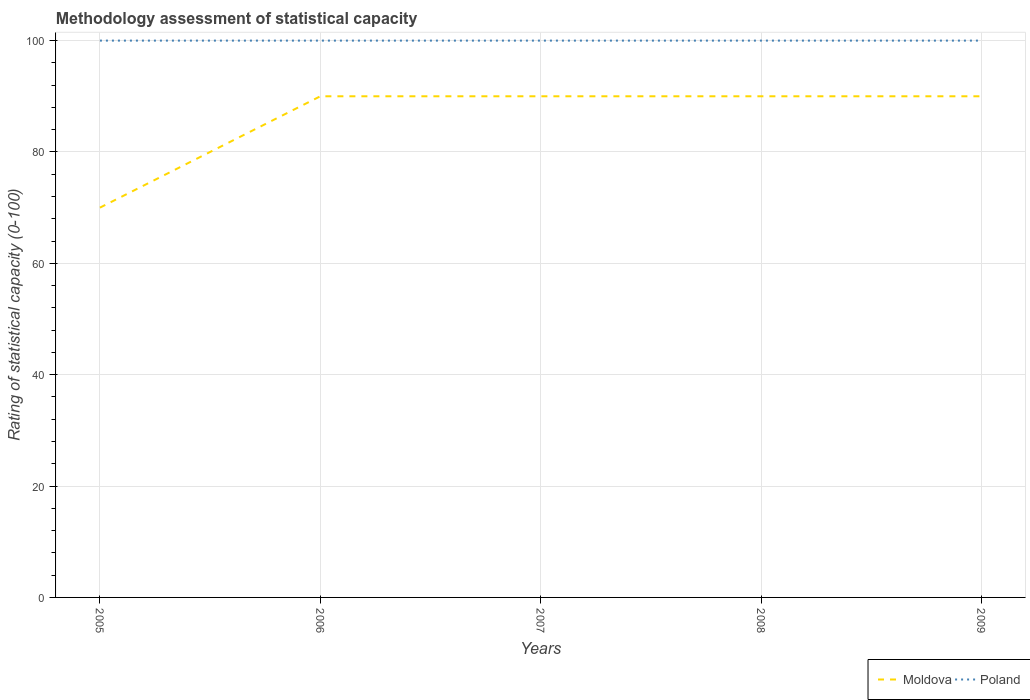How many different coloured lines are there?
Provide a succinct answer. 2. Across all years, what is the maximum rating of statistical capacity in Moldova?
Provide a succinct answer. 70. What is the difference between the highest and the second highest rating of statistical capacity in Poland?
Your response must be concise. 0. What is the difference between two consecutive major ticks on the Y-axis?
Your answer should be very brief. 20. Does the graph contain any zero values?
Your answer should be compact. No. Where does the legend appear in the graph?
Keep it short and to the point. Bottom right. How many legend labels are there?
Your response must be concise. 2. How are the legend labels stacked?
Provide a short and direct response. Horizontal. What is the title of the graph?
Your answer should be compact. Methodology assessment of statistical capacity. What is the label or title of the Y-axis?
Give a very brief answer. Rating of statistical capacity (0-100). What is the Rating of statistical capacity (0-100) of Poland in 2005?
Your answer should be very brief. 100. What is the Rating of statistical capacity (0-100) of Moldova in 2006?
Your response must be concise. 90. What is the Rating of statistical capacity (0-100) in Moldova in 2007?
Keep it short and to the point. 90. What is the Rating of statistical capacity (0-100) of Poland in 2007?
Ensure brevity in your answer.  100. What is the Rating of statistical capacity (0-100) of Moldova in 2008?
Ensure brevity in your answer.  90. What is the Rating of statistical capacity (0-100) in Poland in 2008?
Provide a short and direct response. 100. What is the Rating of statistical capacity (0-100) of Moldova in 2009?
Keep it short and to the point. 90. Across all years, what is the maximum Rating of statistical capacity (0-100) in Moldova?
Your answer should be compact. 90. Across all years, what is the minimum Rating of statistical capacity (0-100) of Poland?
Provide a succinct answer. 100. What is the total Rating of statistical capacity (0-100) of Moldova in the graph?
Provide a short and direct response. 430. What is the total Rating of statistical capacity (0-100) in Poland in the graph?
Provide a succinct answer. 500. What is the difference between the Rating of statistical capacity (0-100) in Moldova in 2005 and that in 2006?
Your response must be concise. -20. What is the difference between the Rating of statistical capacity (0-100) of Poland in 2005 and that in 2007?
Make the answer very short. 0. What is the difference between the Rating of statistical capacity (0-100) of Poland in 2005 and that in 2009?
Ensure brevity in your answer.  0. What is the difference between the Rating of statistical capacity (0-100) of Moldova in 2006 and that in 2007?
Give a very brief answer. 0. What is the difference between the Rating of statistical capacity (0-100) of Poland in 2006 and that in 2007?
Your answer should be very brief. 0. What is the difference between the Rating of statistical capacity (0-100) in Poland in 2006 and that in 2008?
Give a very brief answer. 0. What is the difference between the Rating of statistical capacity (0-100) of Moldova in 2007 and that in 2008?
Offer a terse response. 0. What is the difference between the Rating of statistical capacity (0-100) in Poland in 2007 and that in 2008?
Offer a very short reply. 0. What is the difference between the Rating of statistical capacity (0-100) in Poland in 2008 and that in 2009?
Your response must be concise. 0. What is the difference between the Rating of statistical capacity (0-100) of Moldova in 2005 and the Rating of statistical capacity (0-100) of Poland in 2006?
Keep it short and to the point. -30. What is the difference between the Rating of statistical capacity (0-100) in Moldova in 2006 and the Rating of statistical capacity (0-100) in Poland in 2009?
Ensure brevity in your answer.  -10. What is the difference between the Rating of statistical capacity (0-100) of Moldova in 2008 and the Rating of statistical capacity (0-100) of Poland in 2009?
Provide a short and direct response. -10. What is the average Rating of statistical capacity (0-100) in Poland per year?
Ensure brevity in your answer.  100. In the year 2005, what is the difference between the Rating of statistical capacity (0-100) in Moldova and Rating of statistical capacity (0-100) in Poland?
Ensure brevity in your answer.  -30. In the year 2008, what is the difference between the Rating of statistical capacity (0-100) in Moldova and Rating of statistical capacity (0-100) in Poland?
Your answer should be very brief. -10. In the year 2009, what is the difference between the Rating of statistical capacity (0-100) of Moldova and Rating of statistical capacity (0-100) of Poland?
Your answer should be compact. -10. What is the ratio of the Rating of statistical capacity (0-100) of Moldova in 2005 to that in 2006?
Your answer should be very brief. 0.78. What is the ratio of the Rating of statistical capacity (0-100) of Poland in 2005 to that in 2006?
Your answer should be very brief. 1. What is the ratio of the Rating of statistical capacity (0-100) in Poland in 2005 to that in 2007?
Your answer should be very brief. 1. What is the ratio of the Rating of statistical capacity (0-100) of Moldova in 2005 to that in 2009?
Ensure brevity in your answer.  0.78. What is the ratio of the Rating of statistical capacity (0-100) of Poland in 2005 to that in 2009?
Provide a succinct answer. 1. What is the ratio of the Rating of statistical capacity (0-100) of Moldova in 2006 to that in 2009?
Offer a very short reply. 1. What is the ratio of the Rating of statistical capacity (0-100) of Poland in 2006 to that in 2009?
Offer a very short reply. 1. What is the ratio of the Rating of statistical capacity (0-100) in Moldova in 2007 to that in 2008?
Your answer should be compact. 1. What is the ratio of the Rating of statistical capacity (0-100) of Poland in 2007 to that in 2009?
Your response must be concise. 1. What is the ratio of the Rating of statistical capacity (0-100) in Poland in 2008 to that in 2009?
Your answer should be very brief. 1. 